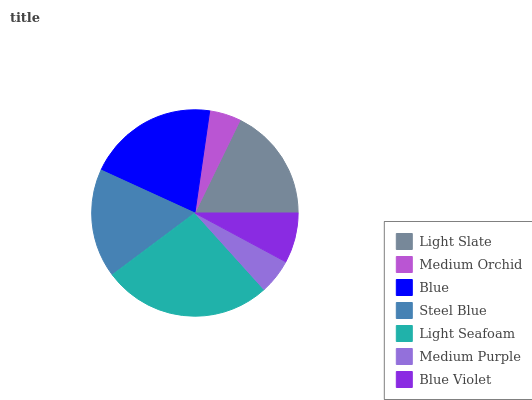Is Medium Orchid the minimum?
Answer yes or no. Yes. Is Light Seafoam the maximum?
Answer yes or no. Yes. Is Blue the minimum?
Answer yes or no. No. Is Blue the maximum?
Answer yes or no. No. Is Blue greater than Medium Orchid?
Answer yes or no. Yes. Is Medium Orchid less than Blue?
Answer yes or no. Yes. Is Medium Orchid greater than Blue?
Answer yes or no. No. Is Blue less than Medium Orchid?
Answer yes or no. No. Is Steel Blue the high median?
Answer yes or no. Yes. Is Steel Blue the low median?
Answer yes or no. Yes. Is Blue the high median?
Answer yes or no. No. Is Light Slate the low median?
Answer yes or no. No. 